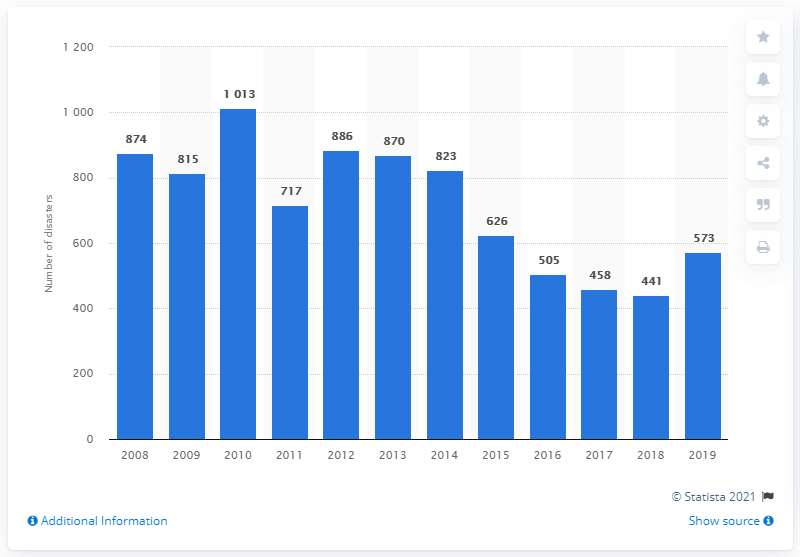Indicate a few pertinent items in this graphic. In 2019, a total of 573 disasters were registered with the federal police. 